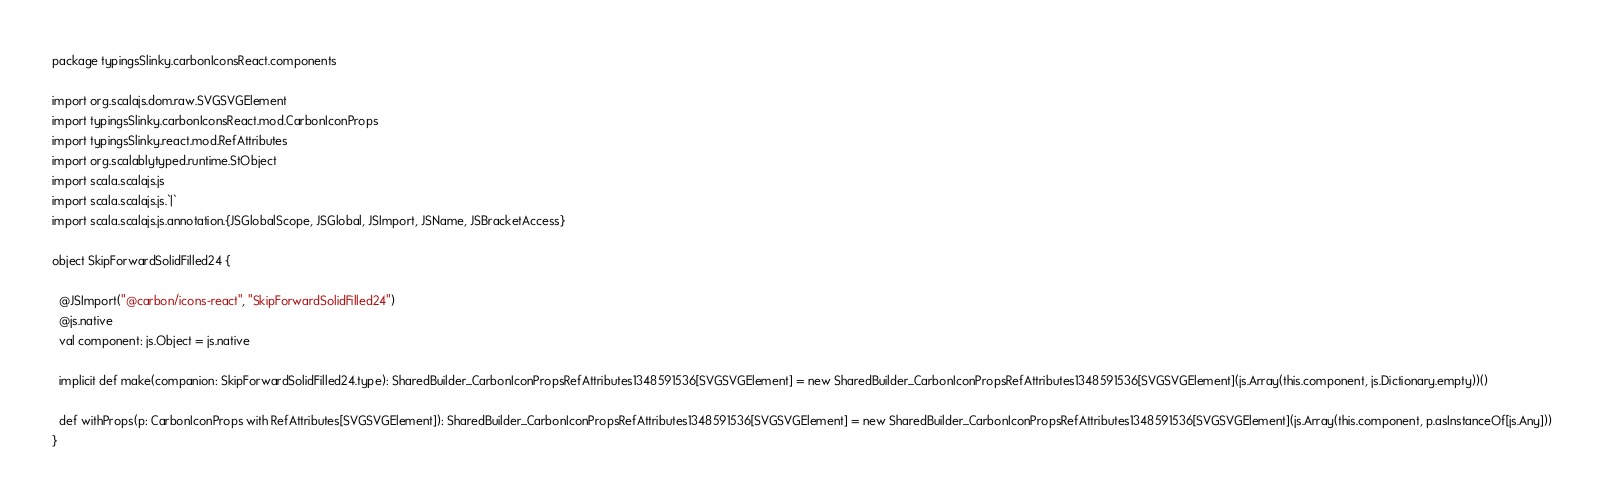<code> <loc_0><loc_0><loc_500><loc_500><_Scala_>package typingsSlinky.carbonIconsReact.components

import org.scalajs.dom.raw.SVGSVGElement
import typingsSlinky.carbonIconsReact.mod.CarbonIconProps
import typingsSlinky.react.mod.RefAttributes
import org.scalablytyped.runtime.StObject
import scala.scalajs.js
import scala.scalajs.js.`|`
import scala.scalajs.js.annotation.{JSGlobalScope, JSGlobal, JSImport, JSName, JSBracketAccess}

object SkipForwardSolidFilled24 {
  
  @JSImport("@carbon/icons-react", "SkipForwardSolidFilled24")
  @js.native
  val component: js.Object = js.native
  
  implicit def make(companion: SkipForwardSolidFilled24.type): SharedBuilder_CarbonIconPropsRefAttributes1348591536[SVGSVGElement] = new SharedBuilder_CarbonIconPropsRefAttributes1348591536[SVGSVGElement](js.Array(this.component, js.Dictionary.empty))()
  
  def withProps(p: CarbonIconProps with RefAttributes[SVGSVGElement]): SharedBuilder_CarbonIconPropsRefAttributes1348591536[SVGSVGElement] = new SharedBuilder_CarbonIconPropsRefAttributes1348591536[SVGSVGElement](js.Array(this.component, p.asInstanceOf[js.Any]))
}
</code> 